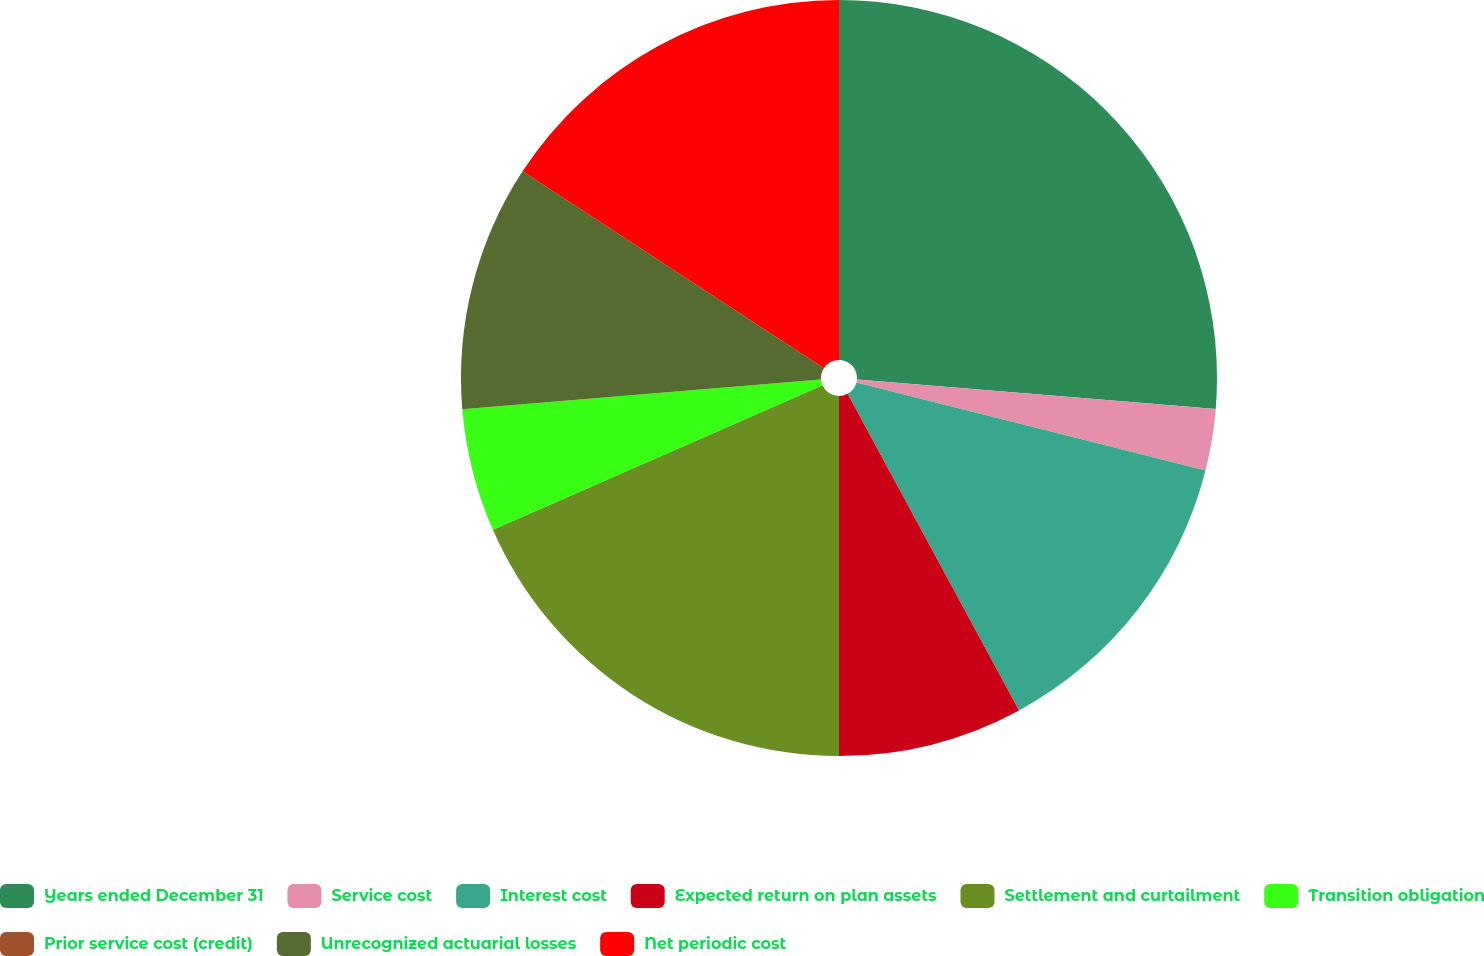<chart> <loc_0><loc_0><loc_500><loc_500><pie_chart><fcel>Years ended December 31<fcel>Service cost<fcel>Interest cost<fcel>Expected return on plan assets<fcel>Settlement and curtailment<fcel>Transition obligation<fcel>Prior service cost (credit)<fcel>Unrecognized actuarial losses<fcel>Net periodic cost<nl><fcel>26.31%<fcel>2.63%<fcel>13.16%<fcel>7.9%<fcel>18.42%<fcel>5.26%<fcel>0.0%<fcel>10.53%<fcel>15.79%<nl></chart> 